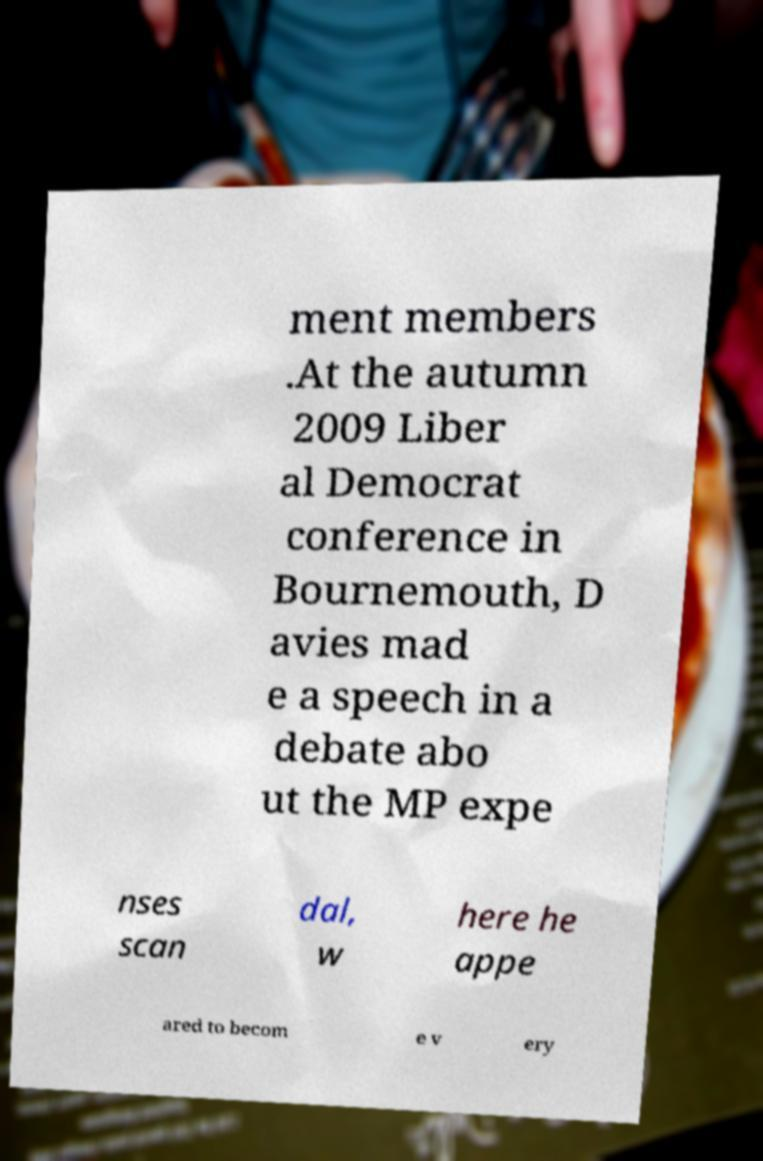What messages or text are displayed in this image? I need them in a readable, typed format. ment members .At the autumn 2009 Liber al Democrat conference in Bournemouth, D avies mad e a speech in a debate abo ut the MP expe nses scan dal, w here he appe ared to becom e v ery 